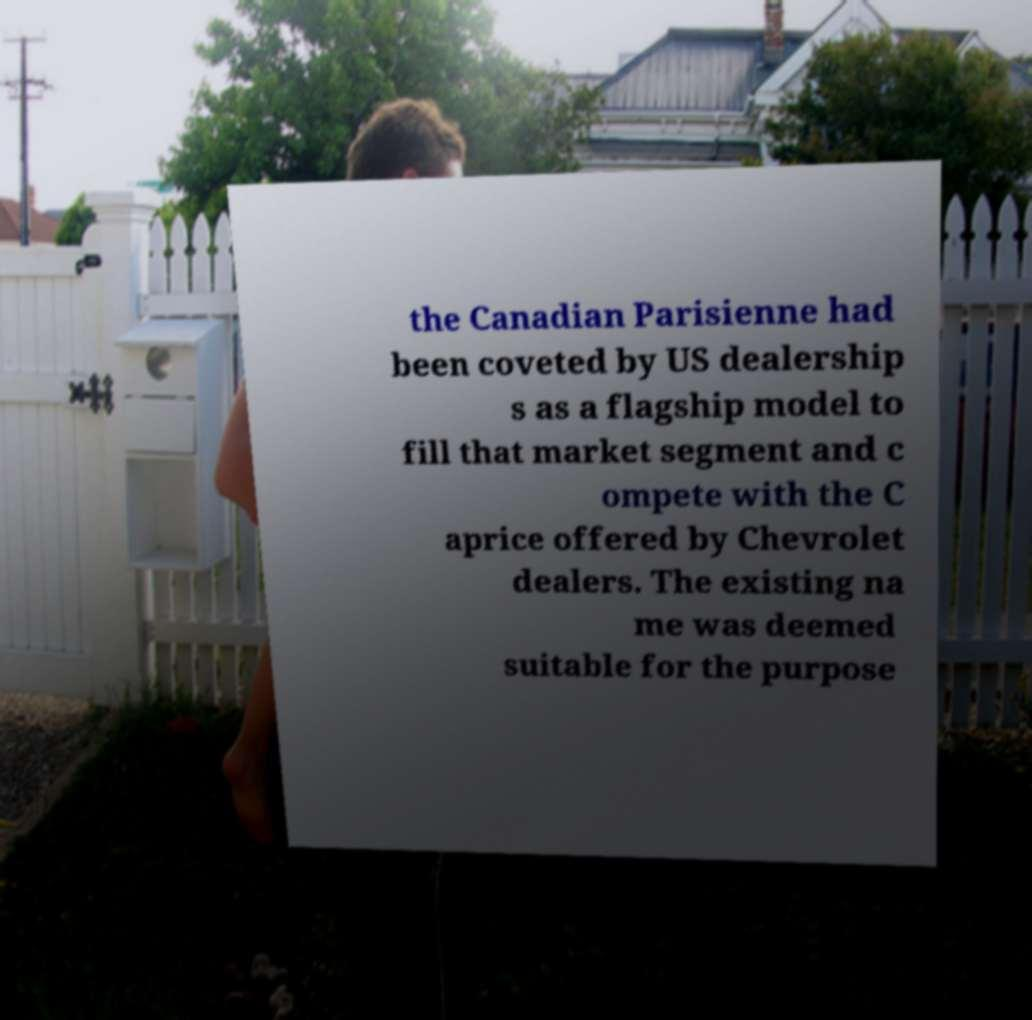What messages or text are displayed in this image? I need them in a readable, typed format. the Canadian Parisienne had been coveted by US dealership s as a flagship model to fill that market segment and c ompete with the C aprice offered by Chevrolet dealers. The existing na me was deemed suitable for the purpose 